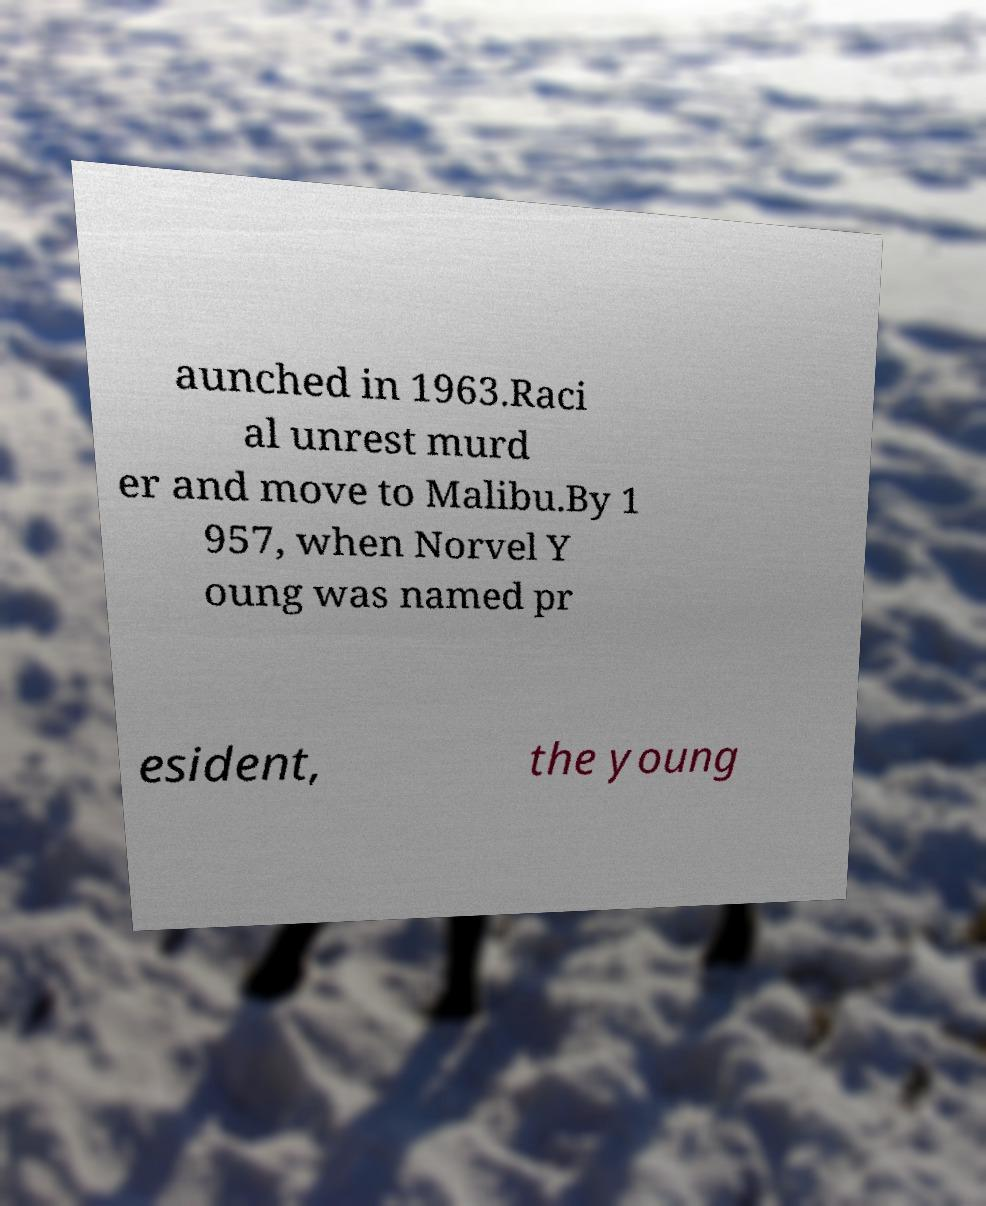Please read and relay the text visible in this image. What does it say? aunched in 1963.Raci al unrest murd er and move to Malibu.By 1 957, when Norvel Y oung was named pr esident, the young 